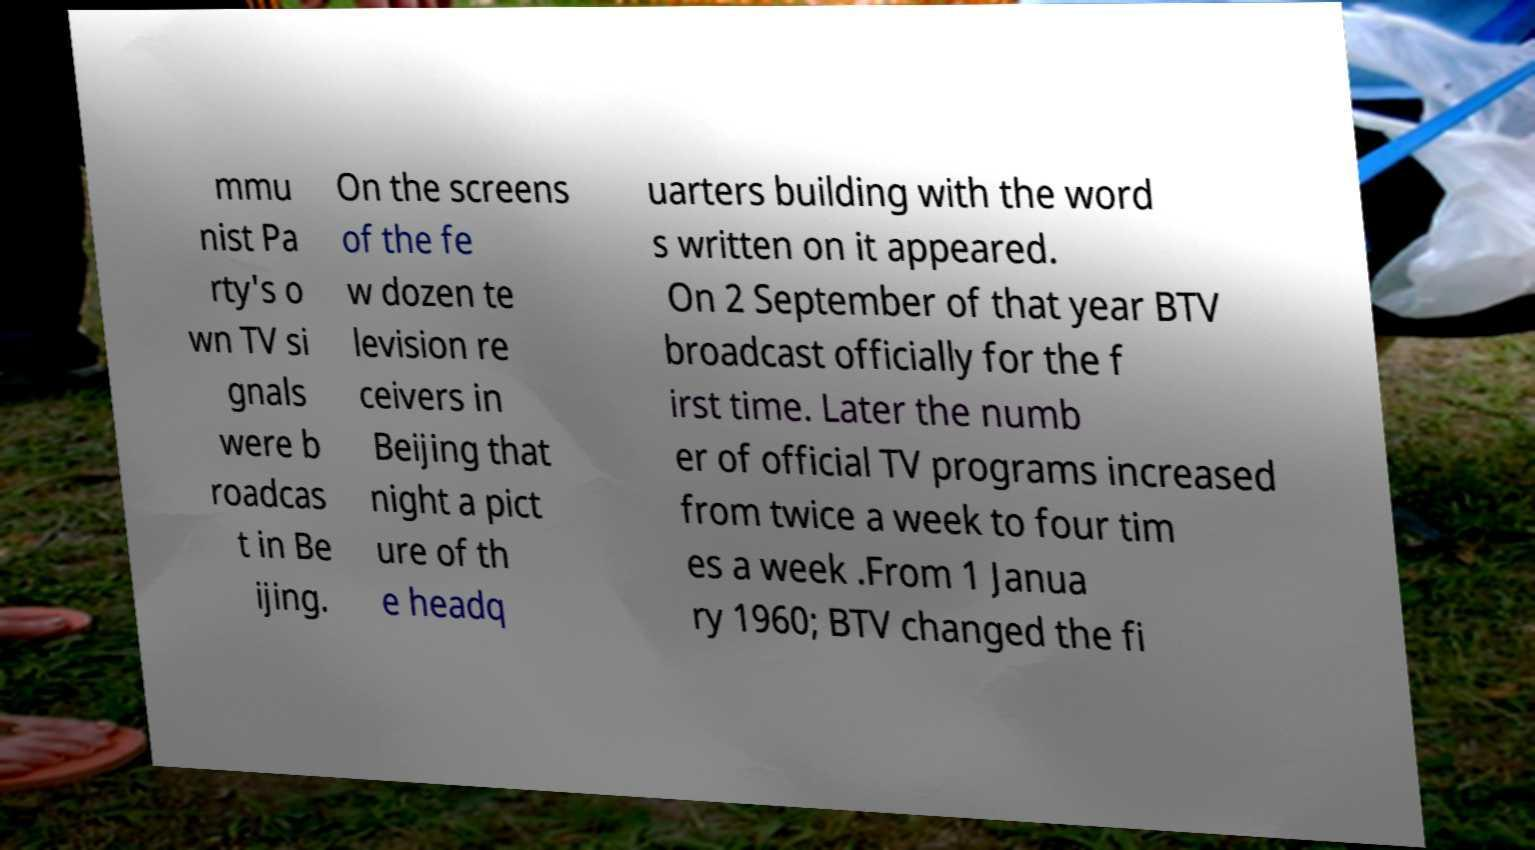Please identify and transcribe the text found in this image. mmu nist Pa rty's o wn TV si gnals were b roadcas t in Be ijing. On the screens of the fe w dozen te levision re ceivers in Beijing that night a pict ure of th e headq uarters building with the word s written on it appeared. On 2 September of that year BTV broadcast officially for the f irst time. Later the numb er of official TV programs increased from twice a week to four tim es a week .From 1 Janua ry 1960; BTV changed the fi 